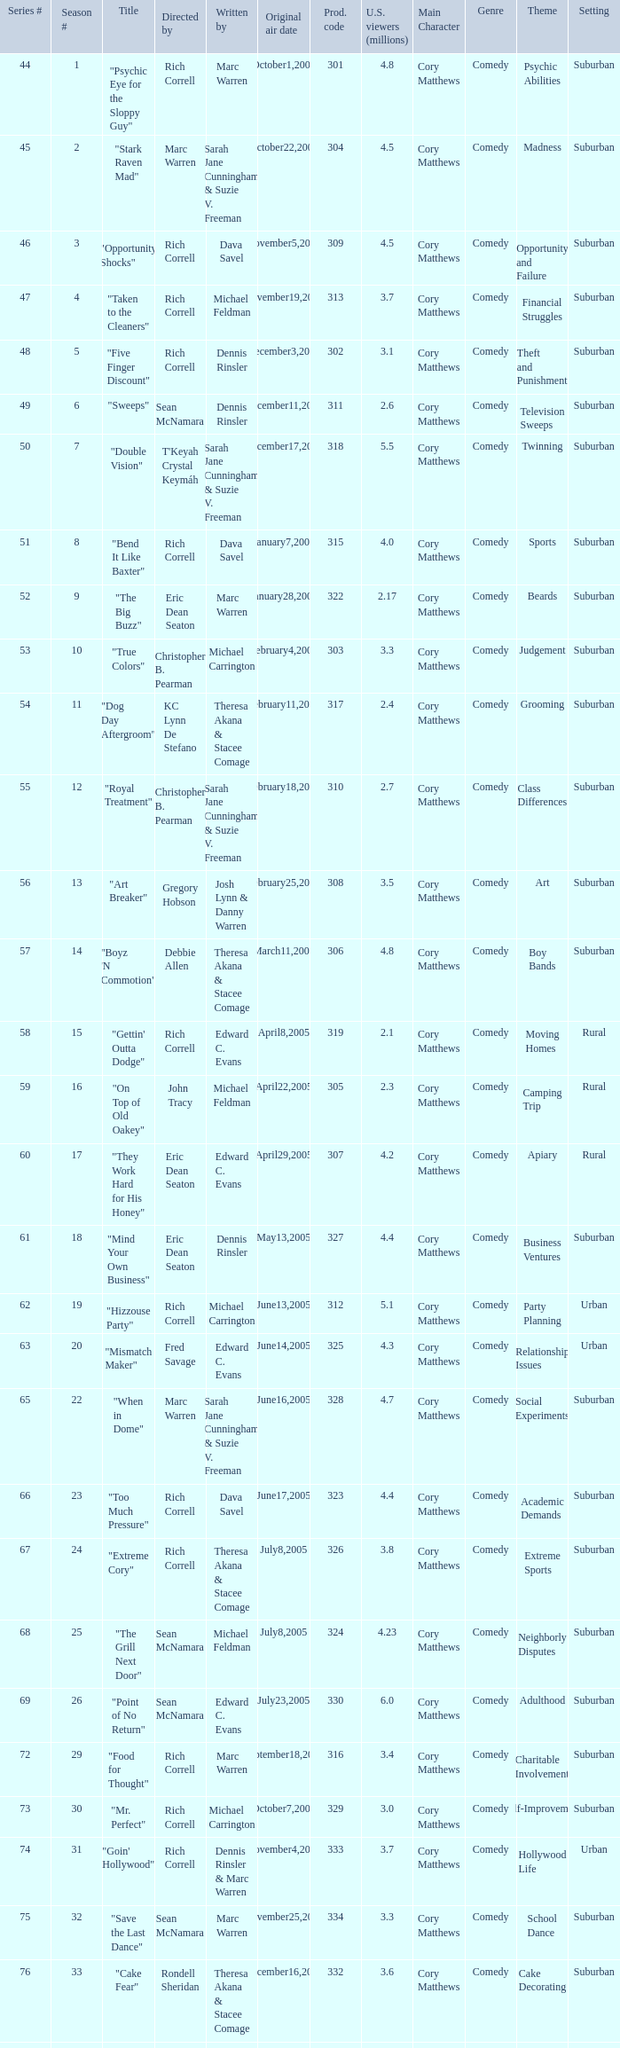What is the title of the episode directed by Rich Correll and written by Dennis Rinsler? "Five Finger Discount". 